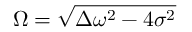Convert formula to latex. <formula><loc_0><loc_0><loc_500><loc_500>\Omega = \sqrt { \Delta \omega ^ { 2 } - 4 \sigma ^ { 2 } }</formula> 